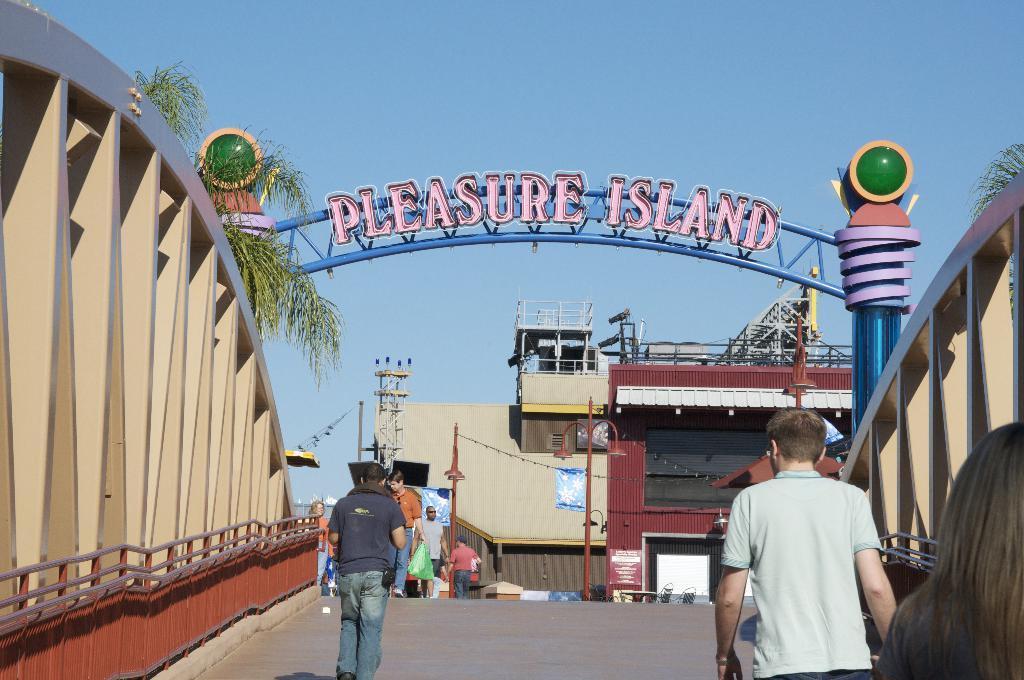Could you give a brief overview of what you see in this image? This image is clicked outside. There are buildings in the middle. There is a bridged, there are some persons walking in the middle. There is sky at the top. There are trees on the left side and right side. 